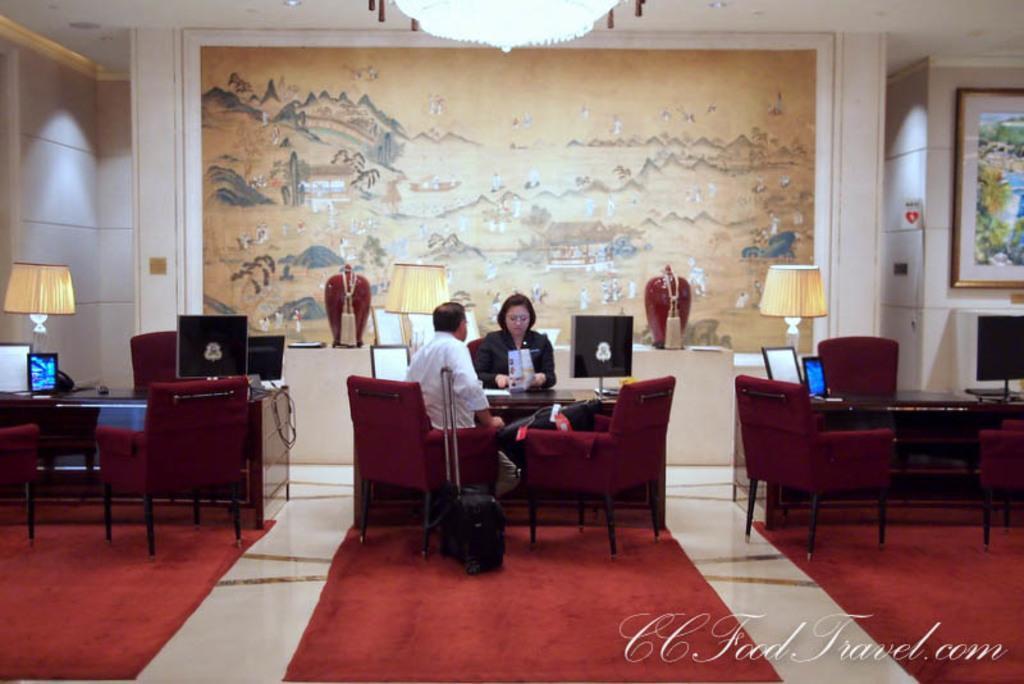Could you give a brief overview of what you see in this image? This picture is of inside. On the right corner we can see a television placed on the table and some chairs and table and we can see a picture frame hanging on the wall and a lamp. In the center there is a man and a woman sitting on the chair. In the foreground we can see the floor which is covered with the red carpet. On the left there is a table on the top of which a laptop and a monitor is placed and there is a side lamp. On the top we can see a Chandelier and in the background we can see a picture frame on the wall and a wall. 